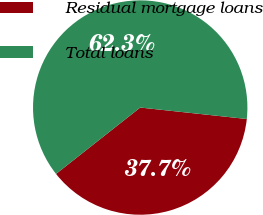Convert chart to OTSL. <chart><loc_0><loc_0><loc_500><loc_500><pie_chart><fcel>Residual mortgage loans<fcel>Total loans<nl><fcel>37.67%<fcel>62.33%<nl></chart> 